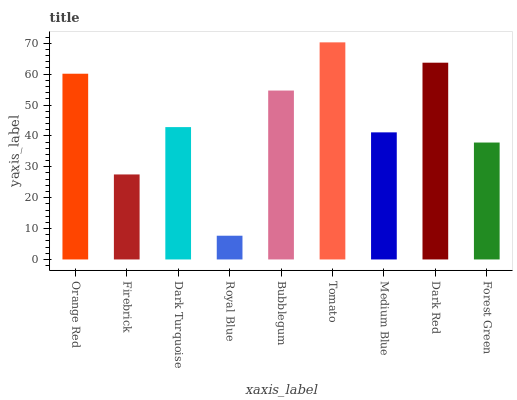Is Royal Blue the minimum?
Answer yes or no. Yes. Is Tomato the maximum?
Answer yes or no. Yes. Is Firebrick the minimum?
Answer yes or no. No. Is Firebrick the maximum?
Answer yes or no. No. Is Orange Red greater than Firebrick?
Answer yes or no. Yes. Is Firebrick less than Orange Red?
Answer yes or no. Yes. Is Firebrick greater than Orange Red?
Answer yes or no. No. Is Orange Red less than Firebrick?
Answer yes or no. No. Is Dark Turquoise the high median?
Answer yes or no. Yes. Is Dark Turquoise the low median?
Answer yes or no. Yes. Is Forest Green the high median?
Answer yes or no. No. Is Medium Blue the low median?
Answer yes or no. No. 